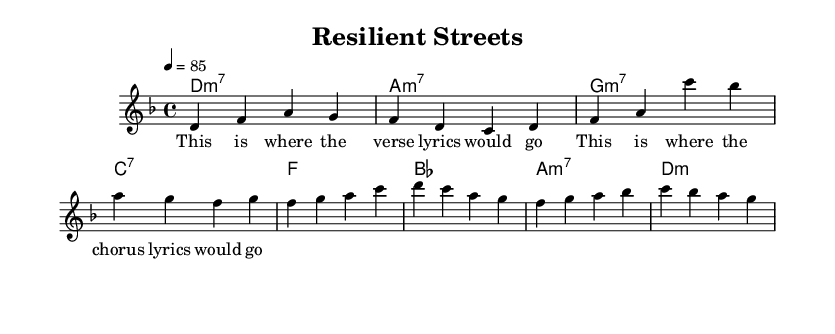What is the key signature of this music? The key signature is D minor, which contains one flat (B flat). This can be determined by looking at the key signature notation at the beginning of the staff.
Answer: D minor What is the time signature of this music? The time signature is 4/4, which indicates that there are four beats in each measure and a quarter note receives one beat. This is indicated by the numbers placed at the start of the score.
Answer: 4/4 What is the tempo marking of this piece? The tempo marking indicates a speed of 85 beats per minute. This is found in the tempo notation that appears at the top of the music.
Answer: 85 Which chord follows the melody section in the verse? The chord that follows the melody section in the verse is A minor 7. This can be identified in the chord symbols located underneath the corresponding measures.
Answer: A minor 7 What is the primary theme of the song as indicated in the title? The primary theme of the song as indicated in the title is resilience and hope in challenging urban environments. This happens to be the main subject suggested by the title "Resilient Streets".
Answer: resilience and hope In the chorus, which chord is played immediately after the F major chord? The chord played immediately after the F major chord is B flat. This follows the chord progression as noted in the chord symbols beneath the melody.
Answer: B flat How many measures are in the verse section? There are eight measures in the verse section, as indicated by the number of phrases laid out with the melody and corresponding chord symbols.
Answer: 8 